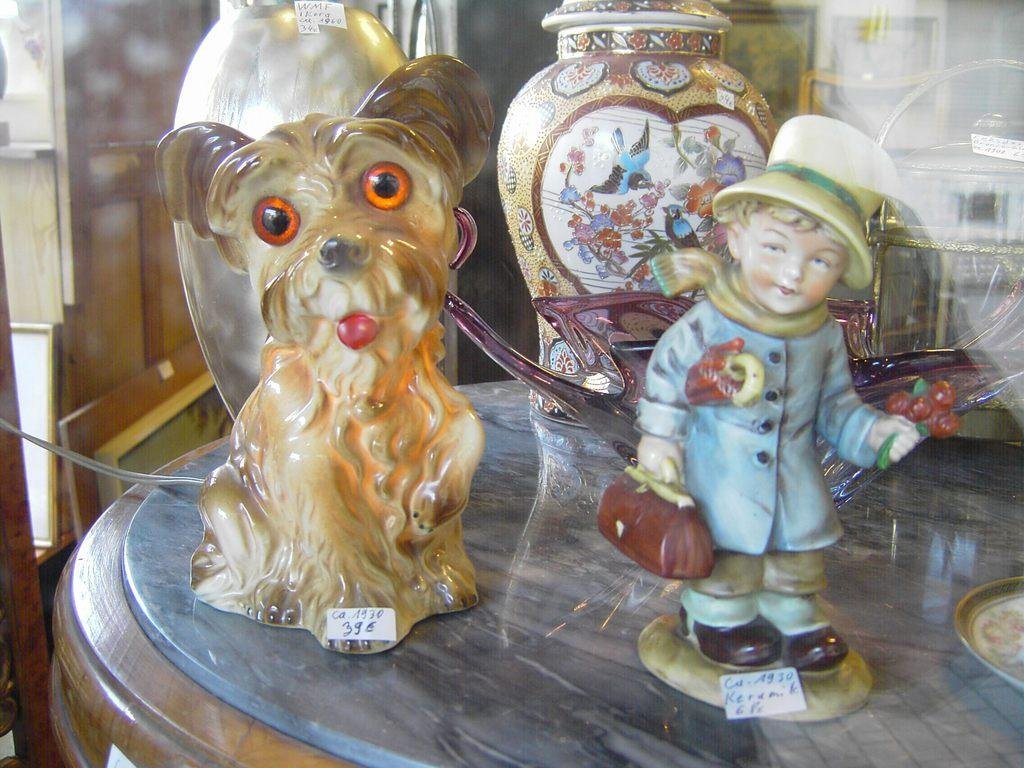What is the main piece of furniture in the image? There is a table in the image. What objects are on the table? There are two ceramic toys, a bowl, and two pots on the table. What type of material is the wall in the background made of? The wall in the background of the image is made of wood. What is located below the wooden wall? There is a photo frame below the wooden wall. What team is playing on the sidewalk in the image? There is no sidewalk or team playing in the image; it features a table with various objects and a wooden wall with a photo frame. 